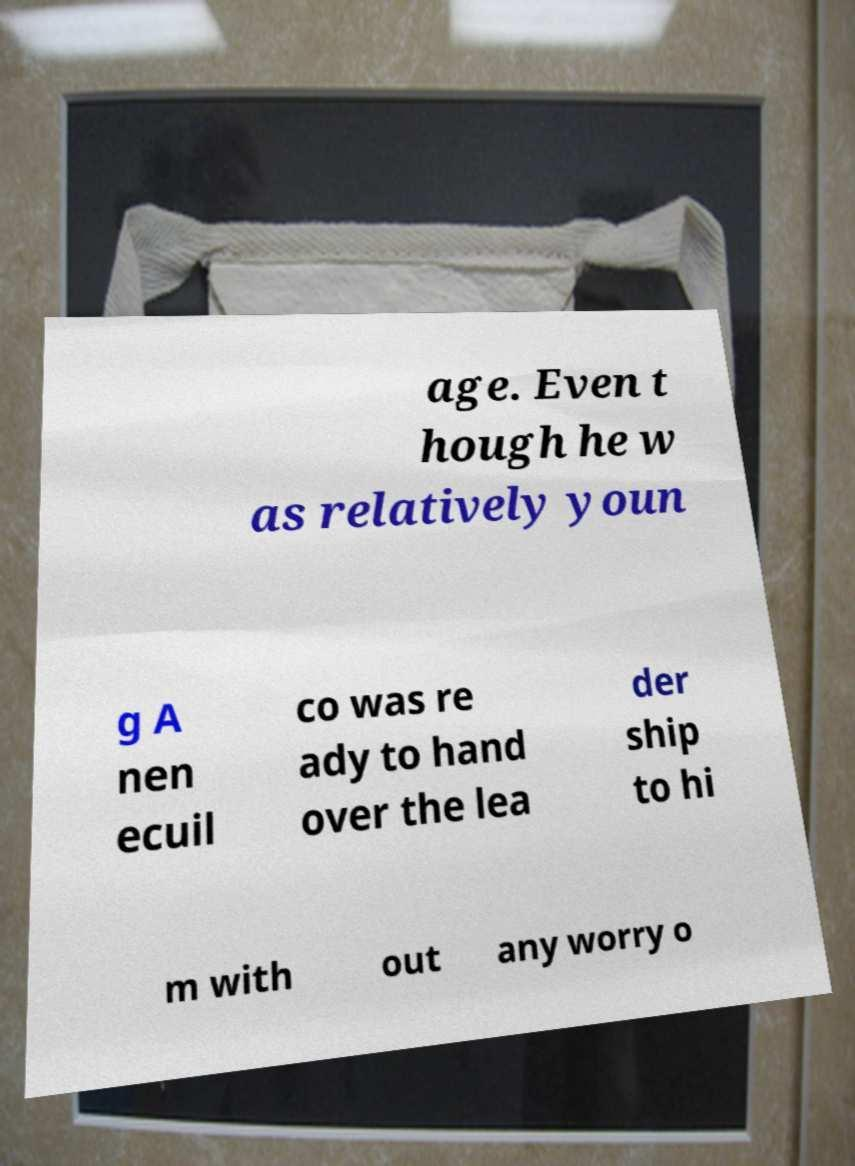For documentation purposes, I need the text within this image transcribed. Could you provide that? age. Even t hough he w as relatively youn g A nen ecuil co was re ady to hand over the lea der ship to hi m with out any worry o 